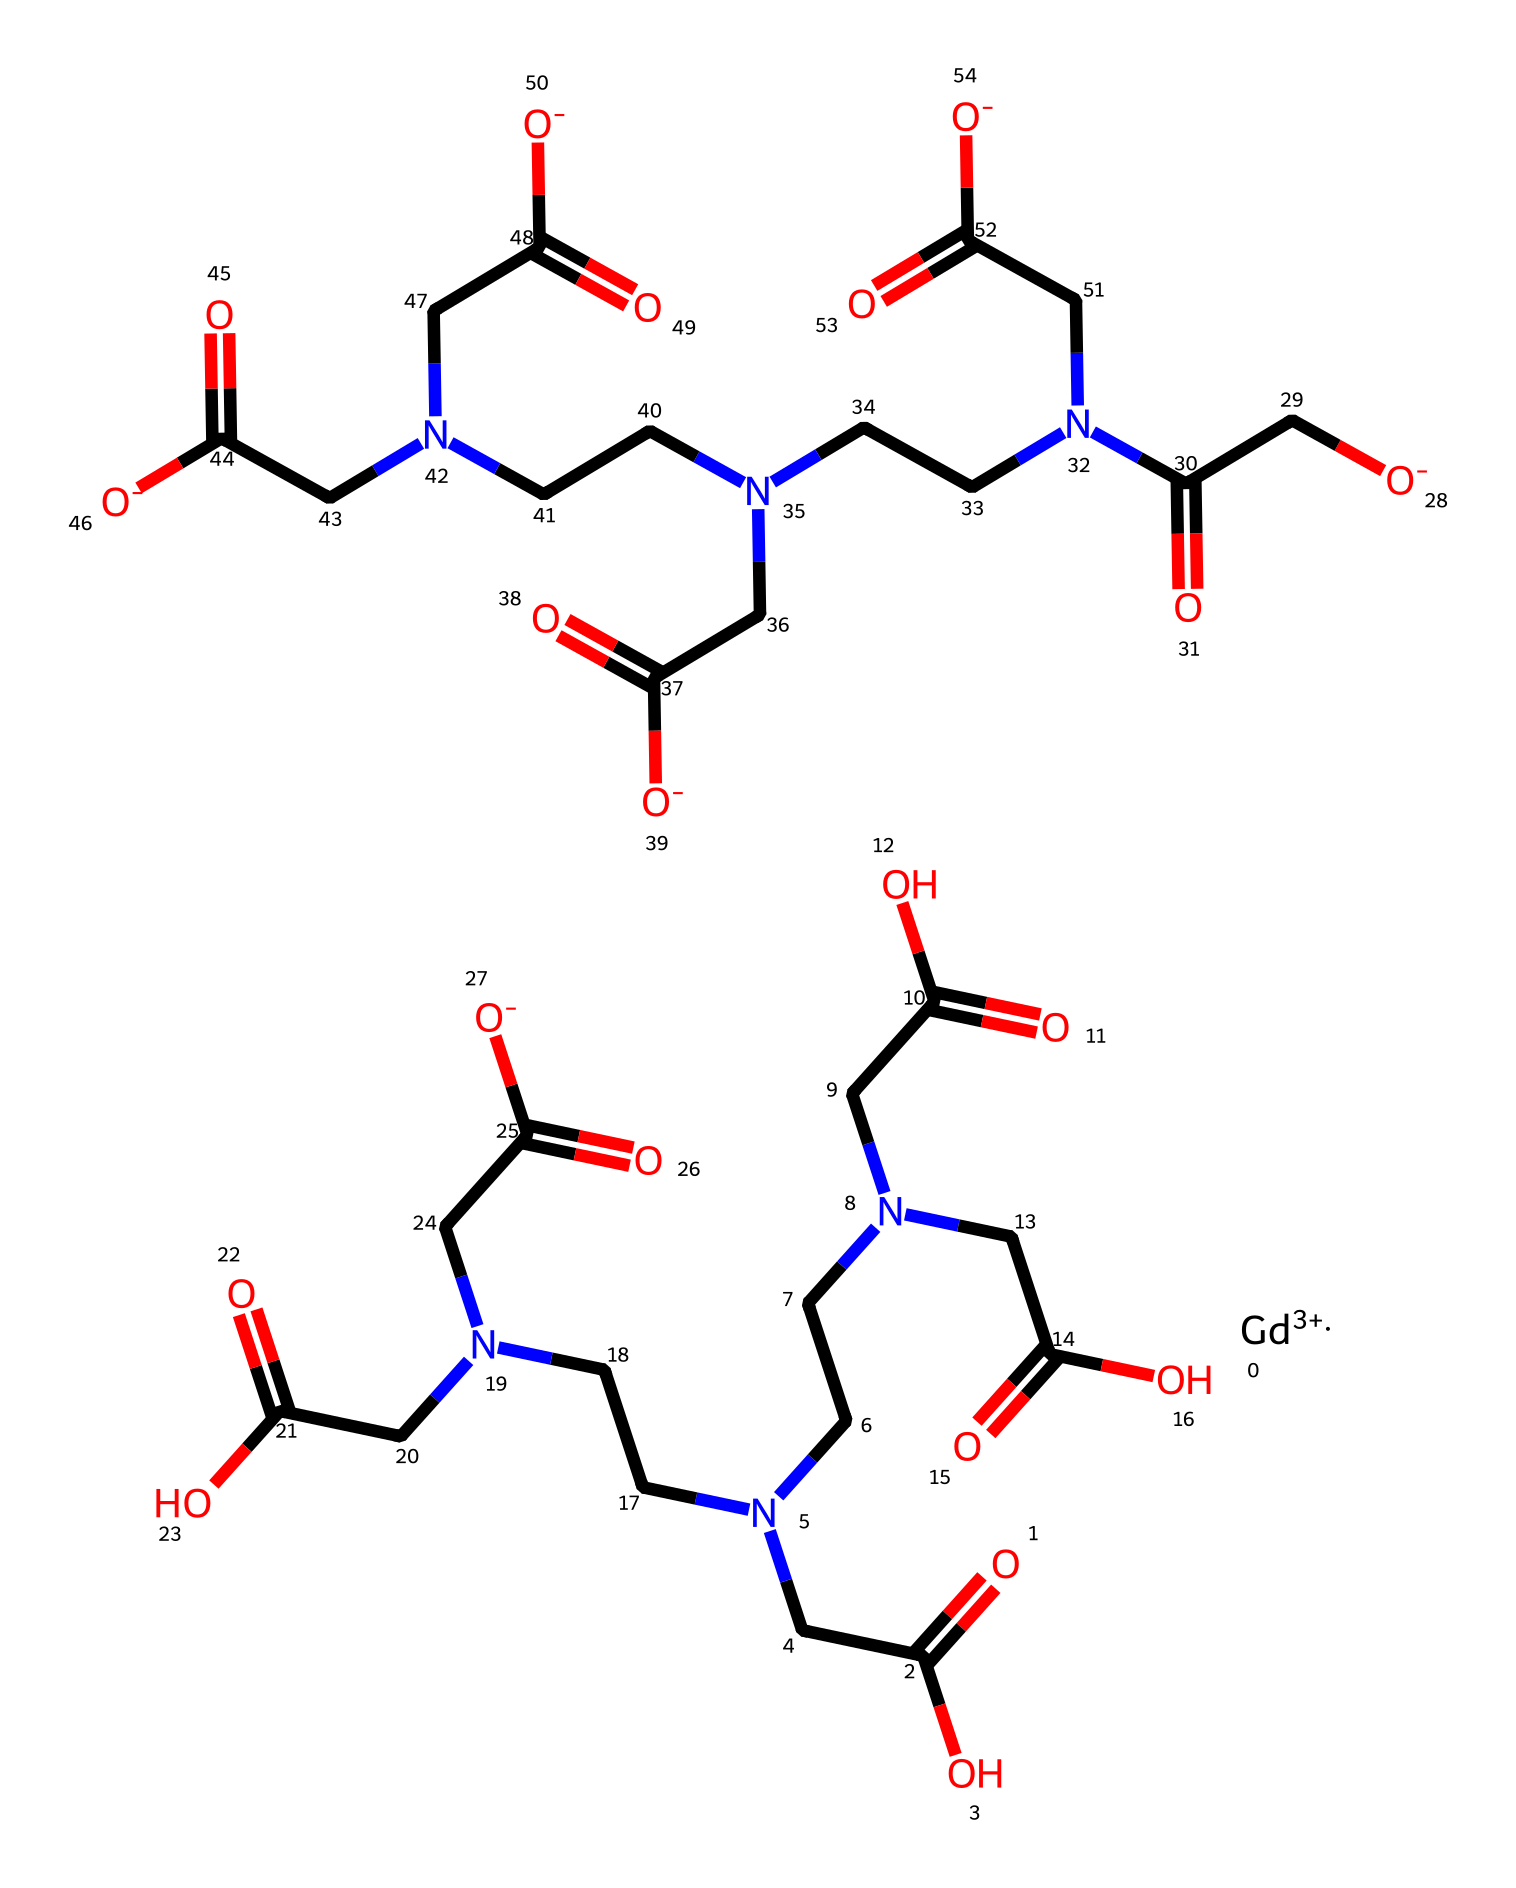What is the oxidation state of gadolinium in this compound? The oxidation state of gadolinium (Gd) can be determined from the notation [Gd+3]. The "+3" indicates that gadolinium has lost three electrons, thus it is in the +3 oxidation state.
Answer: +3 How many carboxylic acid functional groups are present in this structure? To identify the carboxylic acid functional groups, look for the -COOH moiety. In the provided SMILES, there are multiple occurrences of the -C(=O)O notations, indicating carboxylic groups. By counting these, we find there are five distinct carboxylic acid groups in the structure.
Answer: 5 What coordination number is expected for gadolinium in this complex? Gadolinium typically coordinates with donor atoms like nitrogen and oxygen. The number of coordination sites that the central metal can bind is referred to as coordination number. In this structure, there are multiple amine and carboxylate groups observed, suggesting a coordination number of six.
Answer: 6 Which type of chemical bonding is predominantly present in this gadolinium-based contrast agent? In coordination compounds like this, the predominant type of bonding is coordinate covalent bonding, where the donor atoms (ligands) share their lone pairs with the metal (gadolinium) to form a complex.
Answer: coordinate covalent bonding What is the total number of nitrogen atoms present in this coordination compound? By examining the SMILES representation, we can count the nitrogen atoms, which are represented by the letter 'N'. There are six nitrogen atoms connected to the gadolinium ion within the structure.
Answer: 6 What role do the carboxylic acid groups play in this contrast agent? The carboxylic acid groups enhance the solubility of the gadolinium complex in aqueous solutions and improve the complex's ability to relax protons in MRI. They also act as ligands coordinating to the gadolinium center.
Answer: solubility and proton relaxation 